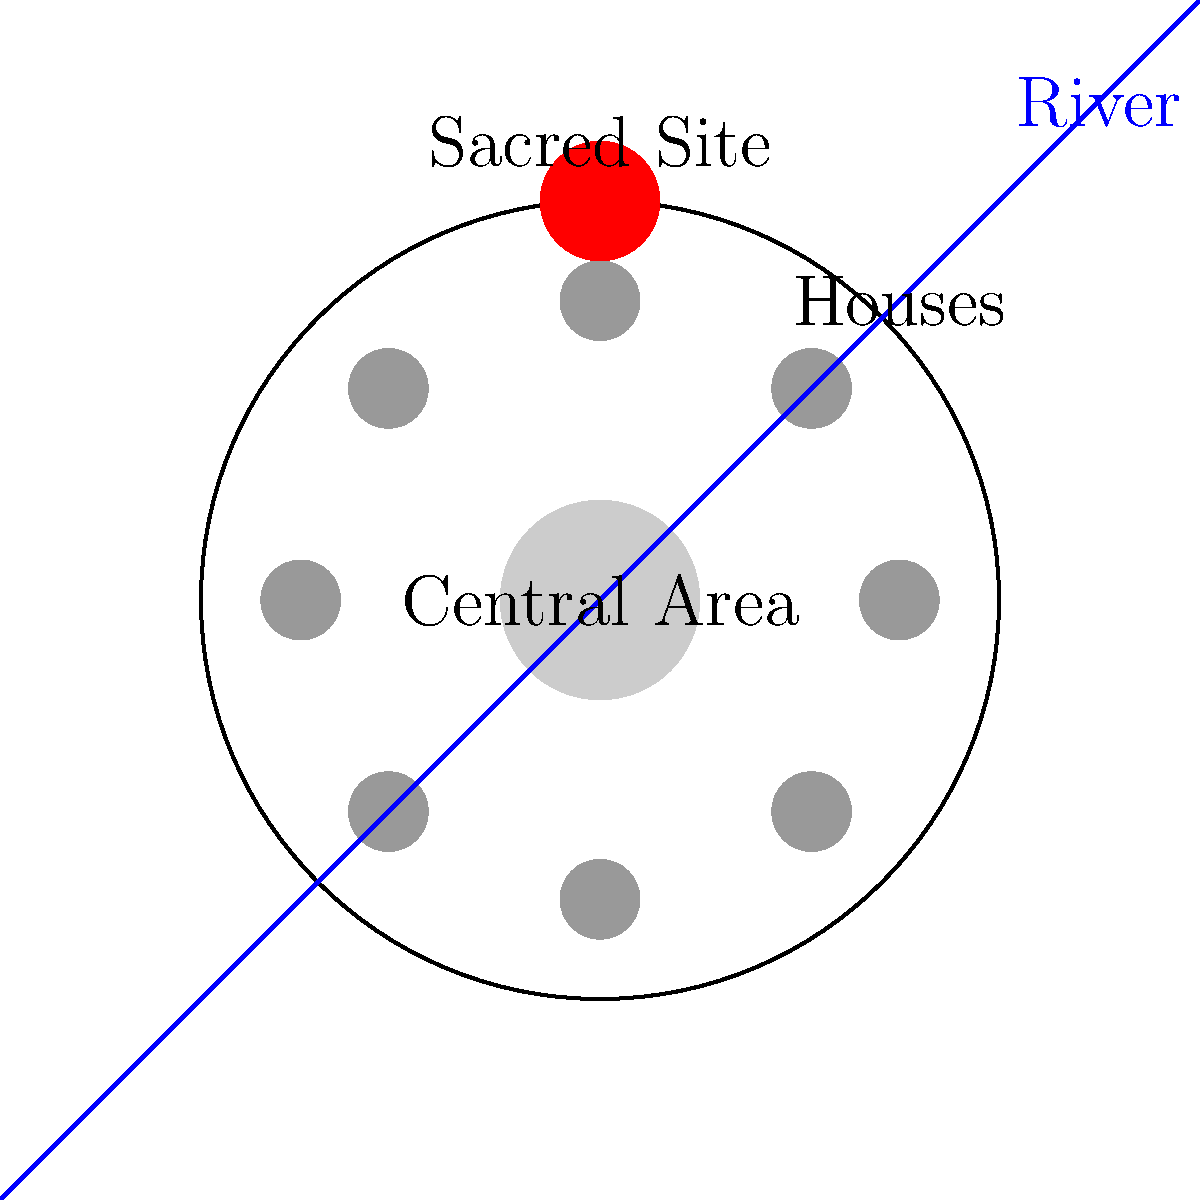In the traditional village layout shown, what percentage of the total village area is dedicated to the central gathering space, and how might this inform modern urban planning for community-focused development? To answer this question, we need to follow these steps:

1. Identify the central gathering area and the total village area.
2. Calculate the areas of both.
3. Determine the percentage of the central area relative to the total area.
4. Interpret the results in the context of modern urban planning.

Step 1: Identification
- The entire village is represented by the large circle.
- The central gathering area is the smaller circle in the center.

Step 2: Area Calculations
- Let's assume the radius of the village circle is $R$ and the radius of the central area is $r$.
- Area of the village (total area): $A_t = \pi R^2$
- Area of the central gathering space: $A_c = \pi r^2$

Step 3: Percentage Calculation
- The ratio of the central area to the total area is: $\frac{A_c}{A_t} = \frac{\pi r^2}{\pi R^2} = (\frac{r}{R})^2$
- From the diagram, we can estimate that $r$ is about 1/4 of $R$.
- Therefore, $(\frac{r}{R})^2 = (\frac{1}{4})^2 = \frac{1}{16} = 0.0625$
- This means the central gathering area is approximately 6.25% of the total village area.

Step 4: Urban Planning Interpretation
- The significant allocation of space (6.25%) to a central gathering area emphasizes the importance of community spaces in traditional village design.
- In modern urban planning, this could inform:
  a) The creation of centralized community spaces or town squares
  b) Allocating a similar percentage of land in new developments for public gathering areas
  c) Designing neighborhoods with a focus on communal interaction and shared spaces
  d) Incorporating cultural and social needs into the physical layout of urban areas

This analysis demonstrates how traditional designs can provide insights for creating more community-focused and culturally sensitive modern urban spaces.
Answer: 6.25%; emphasize central community spaces in modern urban design 